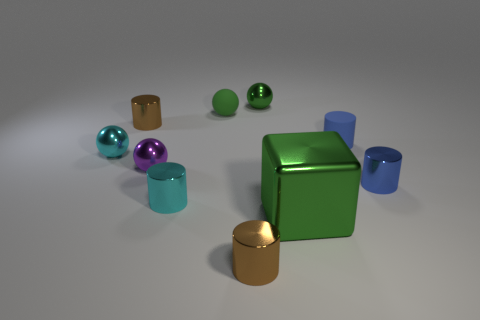Subtract 1 spheres. How many spheres are left? 3 Subtract all cyan cylinders. How many cylinders are left? 4 Subtract all tiny blue rubber cylinders. How many cylinders are left? 4 Subtract all red cylinders. Subtract all blue spheres. How many cylinders are left? 5 Subtract all balls. How many objects are left? 6 Add 3 small purple metallic objects. How many small purple metallic objects exist? 4 Subtract 1 cyan spheres. How many objects are left? 9 Subtract all small purple metal balls. Subtract all large green shiny things. How many objects are left? 8 Add 5 tiny blue matte cylinders. How many tiny blue matte cylinders are left? 6 